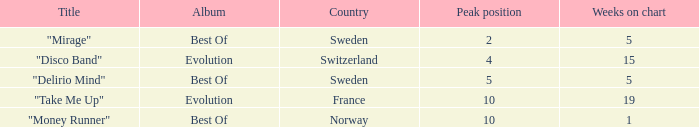Could you parse the entire table as a dict? {'header': ['Title', 'Album', 'Country', 'Peak position', 'Weeks on chart'], 'rows': [['"Mirage"', 'Best Of', 'Sweden', '2', '5'], ['"Disco Band"', 'Evolution', 'Switzerland', '4', '15'], ['"Delirio Mind"', 'Best Of', 'Sweden', '5', '5'], ['"Take Me Up"', 'Evolution', 'France', '10', '19'], ['"Money Runner"', 'Best Of', 'Norway', '10', '1']]} What is the weeks on chart for the single from france? 19.0. 